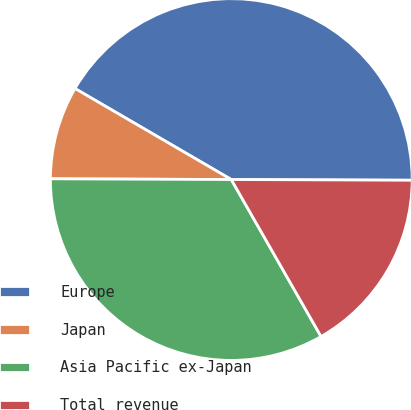Convert chart. <chart><loc_0><loc_0><loc_500><loc_500><pie_chart><fcel>Europe<fcel>Japan<fcel>Asia Pacific ex-Japan<fcel>Total revenue<nl><fcel>41.67%<fcel>8.33%<fcel>33.33%<fcel>16.67%<nl></chart> 